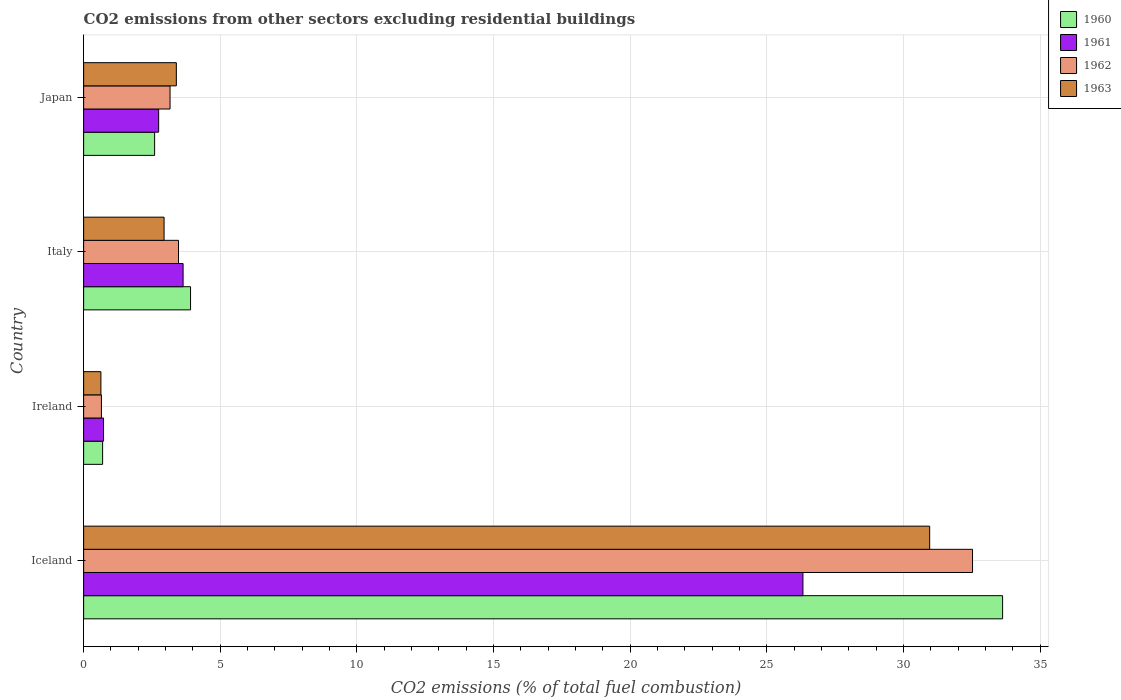Are the number of bars on each tick of the Y-axis equal?
Your answer should be very brief. Yes. How many bars are there on the 4th tick from the bottom?
Provide a succinct answer. 4. What is the label of the 1st group of bars from the top?
Ensure brevity in your answer.  Japan. In how many cases, is the number of bars for a given country not equal to the number of legend labels?
Your response must be concise. 0. What is the total CO2 emitted in 1963 in Japan?
Your answer should be compact. 3.39. Across all countries, what is the maximum total CO2 emitted in 1961?
Your answer should be very brief. 26.32. Across all countries, what is the minimum total CO2 emitted in 1961?
Provide a succinct answer. 0.73. In which country was the total CO2 emitted in 1961 minimum?
Make the answer very short. Ireland. What is the total total CO2 emitted in 1963 in the graph?
Ensure brevity in your answer.  37.92. What is the difference between the total CO2 emitted in 1963 in Ireland and that in Japan?
Provide a succinct answer. -2.76. What is the difference between the total CO2 emitted in 1962 in Italy and the total CO2 emitted in 1961 in Iceland?
Ensure brevity in your answer.  -22.84. What is the average total CO2 emitted in 1960 per country?
Provide a short and direct response. 10.21. What is the difference between the total CO2 emitted in 1960 and total CO2 emitted in 1962 in Italy?
Make the answer very short. 0.44. What is the ratio of the total CO2 emitted in 1963 in Iceland to that in Italy?
Your response must be concise. 10.52. Is the total CO2 emitted in 1960 in Ireland less than that in Japan?
Your answer should be compact. Yes. What is the difference between the highest and the second highest total CO2 emitted in 1961?
Offer a very short reply. 22.68. What is the difference between the highest and the lowest total CO2 emitted in 1962?
Make the answer very short. 31.87. In how many countries, is the total CO2 emitted in 1962 greater than the average total CO2 emitted in 1962 taken over all countries?
Offer a very short reply. 1. Is the sum of the total CO2 emitted in 1961 in Iceland and Ireland greater than the maximum total CO2 emitted in 1962 across all countries?
Keep it short and to the point. No. What does the 4th bar from the bottom in Japan represents?
Offer a very short reply. 1963. Is it the case that in every country, the sum of the total CO2 emitted in 1960 and total CO2 emitted in 1962 is greater than the total CO2 emitted in 1963?
Provide a short and direct response. Yes. Are all the bars in the graph horizontal?
Your answer should be compact. Yes. How many countries are there in the graph?
Keep it short and to the point. 4. What is the difference between two consecutive major ticks on the X-axis?
Make the answer very short. 5. Are the values on the major ticks of X-axis written in scientific E-notation?
Provide a short and direct response. No. Does the graph contain any zero values?
Your response must be concise. No. Does the graph contain grids?
Keep it short and to the point. Yes. Where does the legend appear in the graph?
Offer a very short reply. Top right. What is the title of the graph?
Your answer should be very brief. CO2 emissions from other sectors excluding residential buildings. Does "1991" appear as one of the legend labels in the graph?
Make the answer very short. No. What is the label or title of the X-axis?
Offer a terse response. CO2 emissions (% of total fuel combustion). What is the label or title of the Y-axis?
Make the answer very short. Country. What is the CO2 emissions (% of total fuel combustion) of 1960 in Iceland?
Give a very brief answer. 33.62. What is the CO2 emissions (% of total fuel combustion) in 1961 in Iceland?
Ensure brevity in your answer.  26.32. What is the CO2 emissions (% of total fuel combustion) in 1962 in Iceland?
Offer a terse response. 32.52. What is the CO2 emissions (% of total fuel combustion) in 1963 in Iceland?
Provide a short and direct response. 30.95. What is the CO2 emissions (% of total fuel combustion) in 1960 in Ireland?
Provide a short and direct response. 0.69. What is the CO2 emissions (% of total fuel combustion) of 1961 in Ireland?
Offer a terse response. 0.73. What is the CO2 emissions (% of total fuel combustion) in 1962 in Ireland?
Your response must be concise. 0.65. What is the CO2 emissions (% of total fuel combustion) of 1963 in Ireland?
Keep it short and to the point. 0.63. What is the CO2 emissions (% of total fuel combustion) of 1960 in Italy?
Offer a very short reply. 3.91. What is the CO2 emissions (% of total fuel combustion) in 1961 in Italy?
Keep it short and to the point. 3.64. What is the CO2 emissions (% of total fuel combustion) in 1962 in Italy?
Your answer should be very brief. 3.47. What is the CO2 emissions (% of total fuel combustion) of 1963 in Italy?
Your answer should be very brief. 2.94. What is the CO2 emissions (% of total fuel combustion) in 1960 in Japan?
Ensure brevity in your answer.  2.6. What is the CO2 emissions (% of total fuel combustion) of 1961 in Japan?
Your answer should be compact. 2.74. What is the CO2 emissions (% of total fuel combustion) of 1962 in Japan?
Provide a succinct answer. 3.16. What is the CO2 emissions (% of total fuel combustion) of 1963 in Japan?
Your answer should be very brief. 3.39. Across all countries, what is the maximum CO2 emissions (% of total fuel combustion) in 1960?
Keep it short and to the point. 33.62. Across all countries, what is the maximum CO2 emissions (% of total fuel combustion) in 1961?
Offer a very short reply. 26.32. Across all countries, what is the maximum CO2 emissions (% of total fuel combustion) in 1962?
Your response must be concise. 32.52. Across all countries, what is the maximum CO2 emissions (% of total fuel combustion) in 1963?
Ensure brevity in your answer.  30.95. Across all countries, what is the minimum CO2 emissions (% of total fuel combustion) in 1960?
Make the answer very short. 0.69. Across all countries, what is the minimum CO2 emissions (% of total fuel combustion) in 1961?
Your answer should be very brief. 0.73. Across all countries, what is the minimum CO2 emissions (% of total fuel combustion) of 1962?
Your answer should be compact. 0.65. Across all countries, what is the minimum CO2 emissions (% of total fuel combustion) in 1963?
Ensure brevity in your answer.  0.63. What is the total CO2 emissions (% of total fuel combustion) in 1960 in the graph?
Offer a terse response. 40.82. What is the total CO2 emissions (% of total fuel combustion) of 1961 in the graph?
Ensure brevity in your answer.  33.43. What is the total CO2 emissions (% of total fuel combustion) of 1962 in the graph?
Provide a short and direct response. 39.8. What is the total CO2 emissions (% of total fuel combustion) of 1963 in the graph?
Provide a succinct answer. 37.92. What is the difference between the CO2 emissions (% of total fuel combustion) in 1960 in Iceland and that in Ireland?
Give a very brief answer. 32.93. What is the difference between the CO2 emissions (% of total fuel combustion) of 1961 in Iceland and that in Ireland?
Give a very brief answer. 25.59. What is the difference between the CO2 emissions (% of total fuel combustion) of 1962 in Iceland and that in Ireland?
Offer a terse response. 31.87. What is the difference between the CO2 emissions (% of total fuel combustion) of 1963 in Iceland and that in Ireland?
Offer a very short reply. 30.32. What is the difference between the CO2 emissions (% of total fuel combustion) of 1960 in Iceland and that in Italy?
Make the answer very short. 29.71. What is the difference between the CO2 emissions (% of total fuel combustion) of 1961 in Iceland and that in Italy?
Your response must be concise. 22.68. What is the difference between the CO2 emissions (% of total fuel combustion) of 1962 in Iceland and that in Italy?
Give a very brief answer. 29.05. What is the difference between the CO2 emissions (% of total fuel combustion) in 1963 in Iceland and that in Italy?
Keep it short and to the point. 28.01. What is the difference between the CO2 emissions (% of total fuel combustion) of 1960 in Iceland and that in Japan?
Provide a succinct answer. 31.02. What is the difference between the CO2 emissions (% of total fuel combustion) in 1961 in Iceland and that in Japan?
Ensure brevity in your answer.  23.57. What is the difference between the CO2 emissions (% of total fuel combustion) in 1962 in Iceland and that in Japan?
Keep it short and to the point. 29.36. What is the difference between the CO2 emissions (% of total fuel combustion) in 1963 in Iceland and that in Japan?
Ensure brevity in your answer.  27.56. What is the difference between the CO2 emissions (% of total fuel combustion) in 1960 in Ireland and that in Italy?
Provide a succinct answer. -3.22. What is the difference between the CO2 emissions (% of total fuel combustion) of 1961 in Ireland and that in Italy?
Provide a succinct answer. -2.91. What is the difference between the CO2 emissions (% of total fuel combustion) in 1962 in Ireland and that in Italy?
Provide a short and direct response. -2.82. What is the difference between the CO2 emissions (% of total fuel combustion) in 1963 in Ireland and that in Italy?
Ensure brevity in your answer.  -2.31. What is the difference between the CO2 emissions (% of total fuel combustion) in 1960 in Ireland and that in Japan?
Give a very brief answer. -1.9. What is the difference between the CO2 emissions (% of total fuel combustion) in 1961 in Ireland and that in Japan?
Ensure brevity in your answer.  -2.02. What is the difference between the CO2 emissions (% of total fuel combustion) of 1962 in Ireland and that in Japan?
Keep it short and to the point. -2.51. What is the difference between the CO2 emissions (% of total fuel combustion) in 1963 in Ireland and that in Japan?
Your answer should be very brief. -2.76. What is the difference between the CO2 emissions (% of total fuel combustion) in 1960 in Italy and that in Japan?
Provide a succinct answer. 1.31. What is the difference between the CO2 emissions (% of total fuel combustion) in 1961 in Italy and that in Japan?
Your answer should be compact. 0.89. What is the difference between the CO2 emissions (% of total fuel combustion) of 1962 in Italy and that in Japan?
Ensure brevity in your answer.  0.31. What is the difference between the CO2 emissions (% of total fuel combustion) of 1963 in Italy and that in Japan?
Offer a terse response. -0.45. What is the difference between the CO2 emissions (% of total fuel combustion) in 1960 in Iceland and the CO2 emissions (% of total fuel combustion) in 1961 in Ireland?
Provide a short and direct response. 32.89. What is the difference between the CO2 emissions (% of total fuel combustion) in 1960 in Iceland and the CO2 emissions (% of total fuel combustion) in 1962 in Ireland?
Your answer should be compact. 32.97. What is the difference between the CO2 emissions (% of total fuel combustion) of 1960 in Iceland and the CO2 emissions (% of total fuel combustion) of 1963 in Ireland?
Your answer should be compact. 32.99. What is the difference between the CO2 emissions (% of total fuel combustion) in 1961 in Iceland and the CO2 emissions (% of total fuel combustion) in 1962 in Ireland?
Provide a succinct answer. 25.66. What is the difference between the CO2 emissions (% of total fuel combustion) in 1961 in Iceland and the CO2 emissions (% of total fuel combustion) in 1963 in Ireland?
Provide a succinct answer. 25.68. What is the difference between the CO2 emissions (% of total fuel combustion) in 1962 in Iceland and the CO2 emissions (% of total fuel combustion) in 1963 in Ireland?
Offer a terse response. 31.89. What is the difference between the CO2 emissions (% of total fuel combustion) in 1960 in Iceland and the CO2 emissions (% of total fuel combustion) in 1961 in Italy?
Make the answer very short. 29.98. What is the difference between the CO2 emissions (% of total fuel combustion) of 1960 in Iceland and the CO2 emissions (% of total fuel combustion) of 1962 in Italy?
Your response must be concise. 30.15. What is the difference between the CO2 emissions (% of total fuel combustion) of 1960 in Iceland and the CO2 emissions (% of total fuel combustion) of 1963 in Italy?
Offer a very short reply. 30.68. What is the difference between the CO2 emissions (% of total fuel combustion) of 1961 in Iceland and the CO2 emissions (% of total fuel combustion) of 1962 in Italy?
Your answer should be compact. 22.84. What is the difference between the CO2 emissions (% of total fuel combustion) in 1961 in Iceland and the CO2 emissions (% of total fuel combustion) in 1963 in Italy?
Give a very brief answer. 23.37. What is the difference between the CO2 emissions (% of total fuel combustion) of 1962 in Iceland and the CO2 emissions (% of total fuel combustion) of 1963 in Italy?
Offer a very short reply. 29.58. What is the difference between the CO2 emissions (% of total fuel combustion) in 1960 in Iceland and the CO2 emissions (% of total fuel combustion) in 1961 in Japan?
Make the answer very short. 30.88. What is the difference between the CO2 emissions (% of total fuel combustion) of 1960 in Iceland and the CO2 emissions (% of total fuel combustion) of 1962 in Japan?
Keep it short and to the point. 30.46. What is the difference between the CO2 emissions (% of total fuel combustion) of 1960 in Iceland and the CO2 emissions (% of total fuel combustion) of 1963 in Japan?
Make the answer very short. 30.23. What is the difference between the CO2 emissions (% of total fuel combustion) of 1961 in Iceland and the CO2 emissions (% of total fuel combustion) of 1962 in Japan?
Your response must be concise. 23.15. What is the difference between the CO2 emissions (% of total fuel combustion) in 1961 in Iceland and the CO2 emissions (% of total fuel combustion) in 1963 in Japan?
Give a very brief answer. 22.92. What is the difference between the CO2 emissions (% of total fuel combustion) of 1962 in Iceland and the CO2 emissions (% of total fuel combustion) of 1963 in Japan?
Your response must be concise. 29.13. What is the difference between the CO2 emissions (% of total fuel combustion) of 1960 in Ireland and the CO2 emissions (% of total fuel combustion) of 1961 in Italy?
Provide a short and direct response. -2.94. What is the difference between the CO2 emissions (% of total fuel combustion) of 1960 in Ireland and the CO2 emissions (% of total fuel combustion) of 1962 in Italy?
Offer a terse response. -2.78. What is the difference between the CO2 emissions (% of total fuel combustion) in 1960 in Ireland and the CO2 emissions (% of total fuel combustion) in 1963 in Italy?
Ensure brevity in your answer.  -2.25. What is the difference between the CO2 emissions (% of total fuel combustion) in 1961 in Ireland and the CO2 emissions (% of total fuel combustion) in 1962 in Italy?
Offer a terse response. -2.74. What is the difference between the CO2 emissions (% of total fuel combustion) in 1961 in Ireland and the CO2 emissions (% of total fuel combustion) in 1963 in Italy?
Your response must be concise. -2.21. What is the difference between the CO2 emissions (% of total fuel combustion) in 1962 in Ireland and the CO2 emissions (% of total fuel combustion) in 1963 in Italy?
Offer a terse response. -2.29. What is the difference between the CO2 emissions (% of total fuel combustion) in 1960 in Ireland and the CO2 emissions (% of total fuel combustion) in 1961 in Japan?
Your answer should be very brief. -2.05. What is the difference between the CO2 emissions (% of total fuel combustion) in 1960 in Ireland and the CO2 emissions (% of total fuel combustion) in 1962 in Japan?
Ensure brevity in your answer.  -2.47. What is the difference between the CO2 emissions (% of total fuel combustion) of 1960 in Ireland and the CO2 emissions (% of total fuel combustion) of 1963 in Japan?
Provide a succinct answer. -2.7. What is the difference between the CO2 emissions (% of total fuel combustion) of 1961 in Ireland and the CO2 emissions (% of total fuel combustion) of 1962 in Japan?
Offer a very short reply. -2.43. What is the difference between the CO2 emissions (% of total fuel combustion) of 1961 in Ireland and the CO2 emissions (% of total fuel combustion) of 1963 in Japan?
Make the answer very short. -2.66. What is the difference between the CO2 emissions (% of total fuel combustion) of 1962 in Ireland and the CO2 emissions (% of total fuel combustion) of 1963 in Japan?
Offer a very short reply. -2.74. What is the difference between the CO2 emissions (% of total fuel combustion) in 1960 in Italy and the CO2 emissions (% of total fuel combustion) in 1961 in Japan?
Your answer should be very brief. 1.17. What is the difference between the CO2 emissions (% of total fuel combustion) in 1960 in Italy and the CO2 emissions (% of total fuel combustion) in 1962 in Japan?
Your answer should be compact. 0.75. What is the difference between the CO2 emissions (% of total fuel combustion) of 1960 in Italy and the CO2 emissions (% of total fuel combustion) of 1963 in Japan?
Make the answer very short. 0.52. What is the difference between the CO2 emissions (% of total fuel combustion) in 1961 in Italy and the CO2 emissions (% of total fuel combustion) in 1962 in Japan?
Your answer should be very brief. 0.48. What is the difference between the CO2 emissions (% of total fuel combustion) in 1961 in Italy and the CO2 emissions (% of total fuel combustion) in 1963 in Japan?
Your answer should be compact. 0.25. What is the difference between the CO2 emissions (% of total fuel combustion) of 1962 in Italy and the CO2 emissions (% of total fuel combustion) of 1963 in Japan?
Keep it short and to the point. 0.08. What is the average CO2 emissions (% of total fuel combustion) of 1960 per country?
Provide a succinct answer. 10.21. What is the average CO2 emissions (% of total fuel combustion) in 1961 per country?
Your response must be concise. 8.36. What is the average CO2 emissions (% of total fuel combustion) in 1962 per country?
Your answer should be very brief. 9.95. What is the average CO2 emissions (% of total fuel combustion) in 1963 per country?
Give a very brief answer. 9.48. What is the difference between the CO2 emissions (% of total fuel combustion) in 1960 and CO2 emissions (% of total fuel combustion) in 1961 in Iceland?
Your answer should be very brief. 7.3. What is the difference between the CO2 emissions (% of total fuel combustion) of 1960 and CO2 emissions (% of total fuel combustion) of 1962 in Iceland?
Your response must be concise. 1.1. What is the difference between the CO2 emissions (% of total fuel combustion) of 1960 and CO2 emissions (% of total fuel combustion) of 1963 in Iceland?
Make the answer very short. 2.67. What is the difference between the CO2 emissions (% of total fuel combustion) of 1961 and CO2 emissions (% of total fuel combustion) of 1962 in Iceland?
Offer a very short reply. -6.2. What is the difference between the CO2 emissions (% of total fuel combustion) in 1961 and CO2 emissions (% of total fuel combustion) in 1963 in Iceland?
Your answer should be very brief. -4.64. What is the difference between the CO2 emissions (% of total fuel combustion) in 1962 and CO2 emissions (% of total fuel combustion) in 1963 in Iceland?
Ensure brevity in your answer.  1.57. What is the difference between the CO2 emissions (% of total fuel combustion) of 1960 and CO2 emissions (% of total fuel combustion) of 1961 in Ireland?
Provide a short and direct response. -0.03. What is the difference between the CO2 emissions (% of total fuel combustion) of 1960 and CO2 emissions (% of total fuel combustion) of 1962 in Ireland?
Your answer should be compact. 0.04. What is the difference between the CO2 emissions (% of total fuel combustion) of 1960 and CO2 emissions (% of total fuel combustion) of 1963 in Ireland?
Give a very brief answer. 0.06. What is the difference between the CO2 emissions (% of total fuel combustion) of 1961 and CO2 emissions (% of total fuel combustion) of 1962 in Ireland?
Offer a very short reply. 0.08. What is the difference between the CO2 emissions (% of total fuel combustion) of 1961 and CO2 emissions (% of total fuel combustion) of 1963 in Ireland?
Your response must be concise. 0.1. What is the difference between the CO2 emissions (% of total fuel combustion) in 1962 and CO2 emissions (% of total fuel combustion) in 1963 in Ireland?
Offer a very short reply. 0.02. What is the difference between the CO2 emissions (% of total fuel combustion) in 1960 and CO2 emissions (% of total fuel combustion) in 1961 in Italy?
Keep it short and to the point. 0.27. What is the difference between the CO2 emissions (% of total fuel combustion) of 1960 and CO2 emissions (% of total fuel combustion) of 1962 in Italy?
Offer a very short reply. 0.44. What is the difference between the CO2 emissions (% of total fuel combustion) in 1961 and CO2 emissions (% of total fuel combustion) in 1962 in Italy?
Give a very brief answer. 0.17. What is the difference between the CO2 emissions (% of total fuel combustion) in 1961 and CO2 emissions (% of total fuel combustion) in 1963 in Italy?
Keep it short and to the point. 0.7. What is the difference between the CO2 emissions (% of total fuel combustion) in 1962 and CO2 emissions (% of total fuel combustion) in 1963 in Italy?
Your answer should be very brief. 0.53. What is the difference between the CO2 emissions (% of total fuel combustion) of 1960 and CO2 emissions (% of total fuel combustion) of 1961 in Japan?
Your answer should be compact. -0.15. What is the difference between the CO2 emissions (% of total fuel combustion) of 1960 and CO2 emissions (% of total fuel combustion) of 1962 in Japan?
Offer a terse response. -0.56. What is the difference between the CO2 emissions (% of total fuel combustion) in 1960 and CO2 emissions (% of total fuel combustion) in 1963 in Japan?
Keep it short and to the point. -0.79. What is the difference between the CO2 emissions (% of total fuel combustion) of 1961 and CO2 emissions (% of total fuel combustion) of 1962 in Japan?
Your answer should be very brief. -0.42. What is the difference between the CO2 emissions (% of total fuel combustion) in 1961 and CO2 emissions (% of total fuel combustion) in 1963 in Japan?
Offer a very short reply. -0.65. What is the difference between the CO2 emissions (% of total fuel combustion) of 1962 and CO2 emissions (% of total fuel combustion) of 1963 in Japan?
Give a very brief answer. -0.23. What is the ratio of the CO2 emissions (% of total fuel combustion) of 1960 in Iceland to that in Ireland?
Your response must be concise. 48.41. What is the ratio of the CO2 emissions (% of total fuel combustion) in 1961 in Iceland to that in Ireland?
Ensure brevity in your answer.  36.11. What is the ratio of the CO2 emissions (% of total fuel combustion) in 1962 in Iceland to that in Ireland?
Provide a succinct answer. 49.94. What is the ratio of the CO2 emissions (% of total fuel combustion) in 1963 in Iceland to that in Ireland?
Ensure brevity in your answer.  48.97. What is the ratio of the CO2 emissions (% of total fuel combustion) of 1960 in Iceland to that in Italy?
Offer a very short reply. 8.6. What is the ratio of the CO2 emissions (% of total fuel combustion) of 1961 in Iceland to that in Italy?
Provide a short and direct response. 7.23. What is the ratio of the CO2 emissions (% of total fuel combustion) of 1962 in Iceland to that in Italy?
Your answer should be compact. 9.37. What is the ratio of the CO2 emissions (% of total fuel combustion) in 1963 in Iceland to that in Italy?
Your response must be concise. 10.52. What is the ratio of the CO2 emissions (% of total fuel combustion) of 1960 in Iceland to that in Japan?
Give a very brief answer. 12.94. What is the ratio of the CO2 emissions (% of total fuel combustion) of 1961 in Iceland to that in Japan?
Keep it short and to the point. 9.59. What is the ratio of the CO2 emissions (% of total fuel combustion) in 1962 in Iceland to that in Japan?
Ensure brevity in your answer.  10.29. What is the ratio of the CO2 emissions (% of total fuel combustion) of 1963 in Iceland to that in Japan?
Offer a terse response. 9.13. What is the ratio of the CO2 emissions (% of total fuel combustion) in 1960 in Ireland to that in Italy?
Ensure brevity in your answer.  0.18. What is the ratio of the CO2 emissions (% of total fuel combustion) in 1961 in Ireland to that in Italy?
Your response must be concise. 0.2. What is the ratio of the CO2 emissions (% of total fuel combustion) in 1962 in Ireland to that in Italy?
Your response must be concise. 0.19. What is the ratio of the CO2 emissions (% of total fuel combustion) in 1963 in Ireland to that in Italy?
Offer a very short reply. 0.21. What is the ratio of the CO2 emissions (% of total fuel combustion) in 1960 in Ireland to that in Japan?
Offer a terse response. 0.27. What is the ratio of the CO2 emissions (% of total fuel combustion) of 1961 in Ireland to that in Japan?
Give a very brief answer. 0.27. What is the ratio of the CO2 emissions (% of total fuel combustion) of 1962 in Ireland to that in Japan?
Offer a very short reply. 0.21. What is the ratio of the CO2 emissions (% of total fuel combustion) of 1963 in Ireland to that in Japan?
Provide a short and direct response. 0.19. What is the ratio of the CO2 emissions (% of total fuel combustion) of 1960 in Italy to that in Japan?
Offer a terse response. 1.51. What is the ratio of the CO2 emissions (% of total fuel combustion) in 1961 in Italy to that in Japan?
Provide a succinct answer. 1.33. What is the ratio of the CO2 emissions (% of total fuel combustion) in 1962 in Italy to that in Japan?
Ensure brevity in your answer.  1.1. What is the ratio of the CO2 emissions (% of total fuel combustion) in 1963 in Italy to that in Japan?
Your answer should be very brief. 0.87. What is the difference between the highest and the second highest CO2 emissions (% of total fuel combustion) of 1960?
Your answer should be compact. 29.71. What is the difference between the highest and the second highest CO2 emissions (% of total fuel combustion) in 1961?
Ensure brevity in your answer.  22.68. What is the difference between the highest and the second highest CO2 emissions (% of total fuel combustion) in 1962?
Provide a short and direct response. 29.05. What is the difference between the highest and the second highest CO2 emissions (% of total fuel combustion) in 1963?
Offer a terse response. 27.56. What is the difference between the highest and the lowest CO2 emissions (% of total fuel combustion) in 1960?
Your answer should be very brief. 32.93. What is the difference between the highest and the lowest CO2 emissions (% of total fuel combustion) in 1961?
Provide a short and direct response. 25.59. What is the difference between the highest and the lowest CO2 emissions (% of total fuel combustion) of 1962?
Give a very brief answer. 31.87. What is the difference between the highest and the lowest CO2 emissions (% of total fuel combustion) of 1963?
Offer a very short reply. 30.32. 